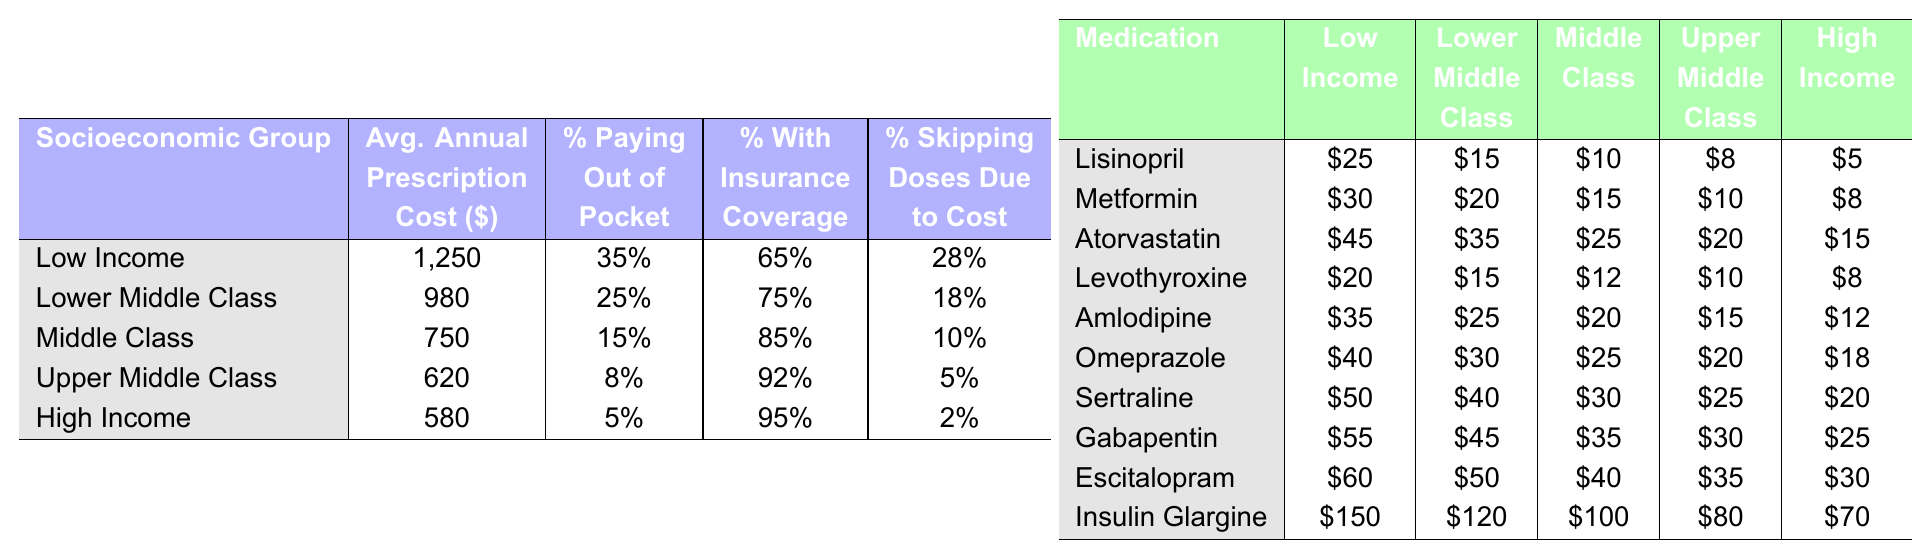What is the average annual prescription cost for the Low Income group? The table shows that the average annual prescription cost for the Low Income group is $1250.
Answer: $1250 Which socioeconomic group has the highest percentage of people paying out of pocket for prescriptions? According to the table, the Low Income group has the highest percentage of people paying out of pocket, at 35%.
Answer: Low Income What is the average percentage of individuals with insurance coverage across all socioeconomic groups? To find the average, we add the percentage of insured individuals from all groups: 65% + 75% + 85% + 92% + 95% = 412%. Then divide by the number of groups (5), which gives us 412% / 5 = 82.4%.
Answer: 82.4% Is it true that the Upper Middle Class has a higher average annual prescription cost than the High Income group? The Upper Middle Class has an average annual prescription cost of $620, while the High Income group has an average of $580. Therefore, it is false that the Upper Middle Class has a higher cost.
Answer: No What is the difference in the percentage of individuals skipping doses due to cost between the Low Income and High Income groups? The percentage of individuals skipping doses due to cost for the Low Income group is 28%, while for the High Income group, it is 2%. The difference is 28% - 2% = 26%.
Answer: 26% Which medication is the least expensive for the Low Income group according to the table? The table indicates that the least expensive medication for the Low Income group is Lisinopril, priced at $25.
Answer: Lisinopril If a Middle Class individual pays 15% out of pocket for prescriptions, what is their average out-of-pocket cost based on their average annual prescription cost? The Middle Class has an average annual prescription cost of $750, and if they pay 15% out of pocket, their out-of-pocket cost is calculated as $750 * 0.15 = $112.50.
Answer: $112.50 How many socioeconomic groups have more than 20% of their individuals skipping doses due to cost? Checking the table, we see that the Low Income (28%), Lower Middle Class (18%), Middle Class (10%), Upper Middle Class (5%), and High Income (2%) groups show that only the Low Income group has more than 20%. That makes it just one group.
Answer: 1 Which socioeconomic group has the lowest annual prescription cost, and what is that cost? The data shows that the High Income group has the lowest average annual prescription cost at $580.
Answer: High Income, $580 If the percentage of individuals with insurance coverage is reduced by 5% in the Lower Middle Class, what would be the new insurance coverage percentage for that group? The current percentage for the Lower Middle Class is 75%. Decreasing this by 5% gives us 75% - 5% = 70%.
Answer: 70% 